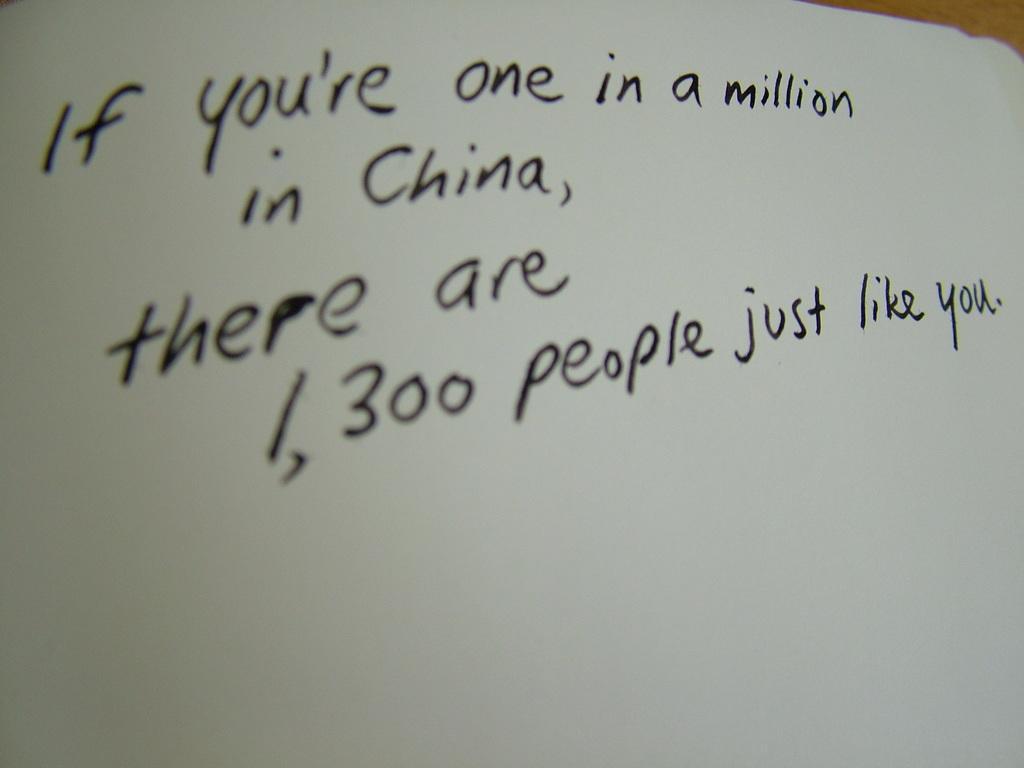In one or two sentences, can you explain what this image depicts? In this image there is text written on a paper. 